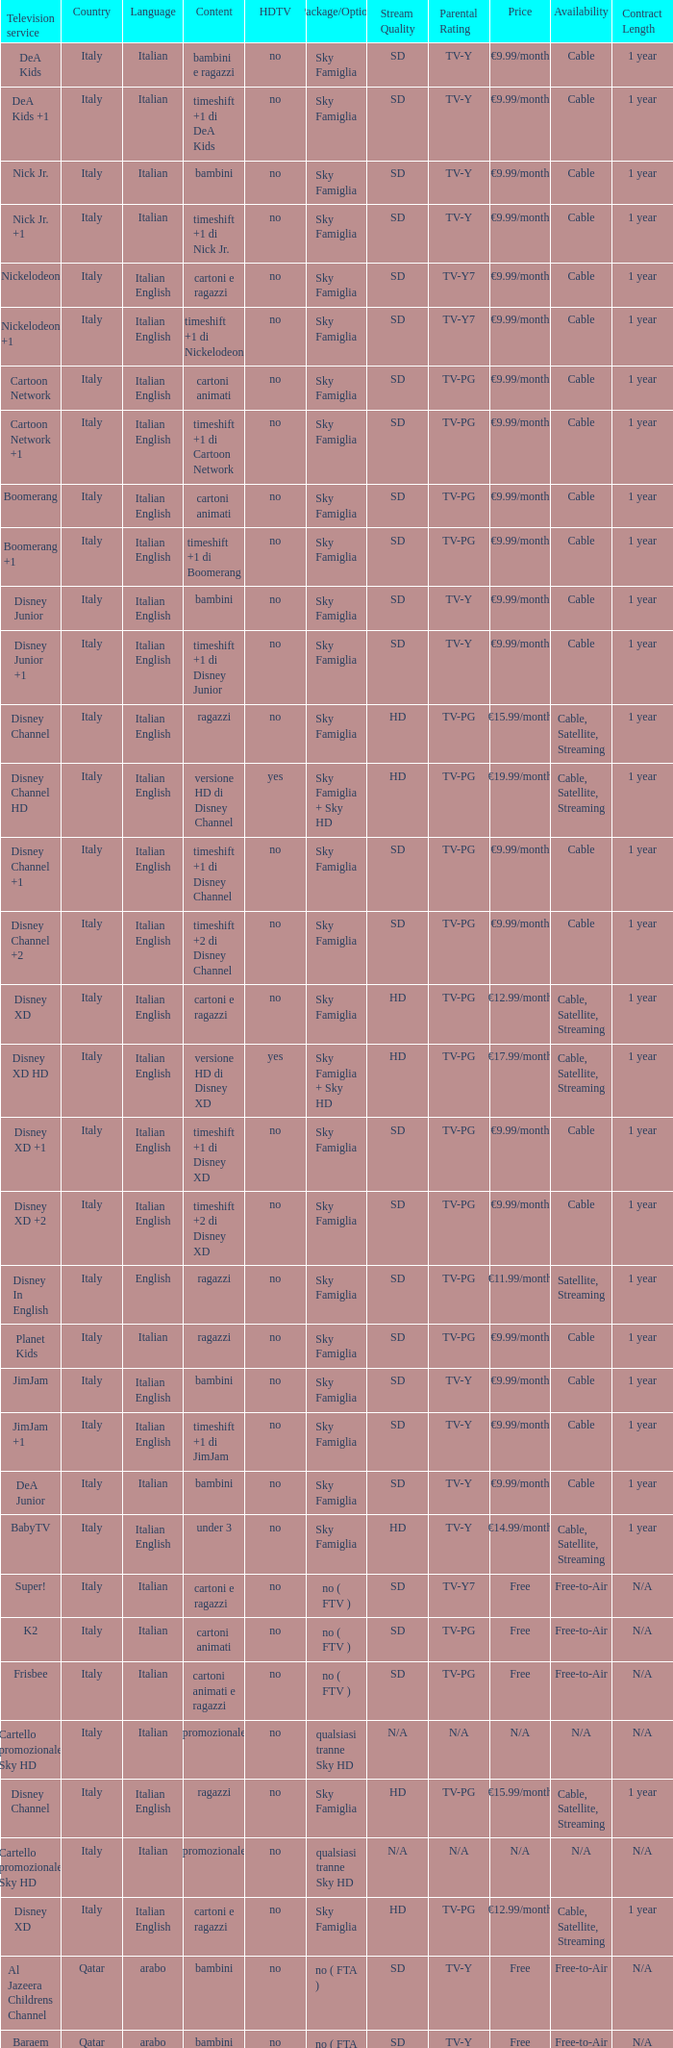What is the Country when the language is italian english, and the television service is disney xd +1? Italy. 